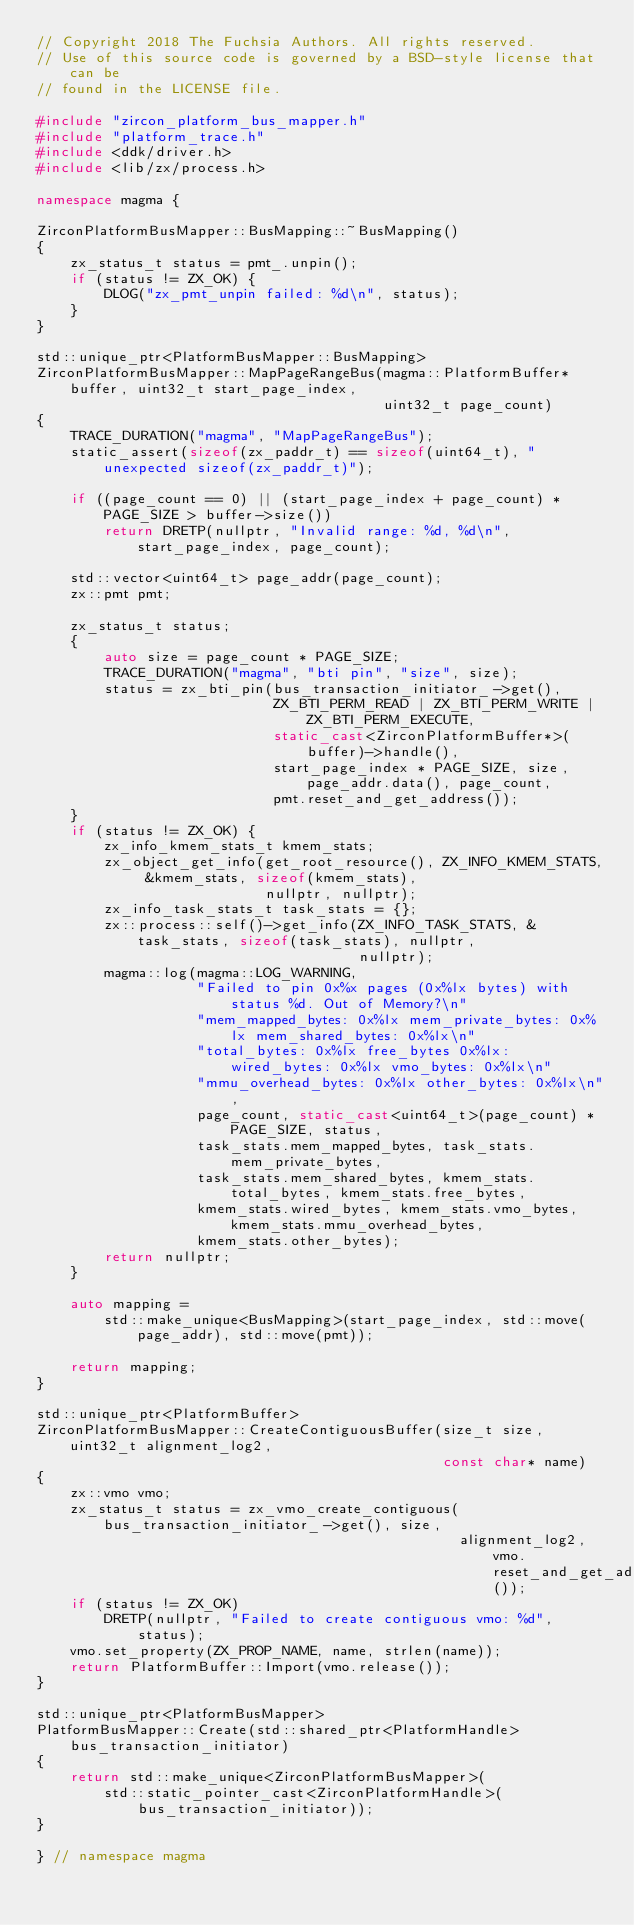Convert code to text. <code><loc_0><loc_0><loc_500><loc_500><_C++_>// Copyright 2018 The Fuchsia Authors. All rights reserved.
// Use of this source code is governed by a BSD-style license that can be
// found in the LICENSE file.

#include "zircon_platform_bus_mapper.h"
#include "platform_trace.h"
#include <ddk/driver.h>
#include <lib/zx/process.h>

namespace magma {

ZirconPlatformBusMapper::BusMapping::~BusMapping()
{
    zx_status_t status = pmt_.unpin();
    if (status != ZX_OK) {
        DLOG("zx_pmt_unpin failed: %d\n", status);
    }
}

std::unique_ptr<PlatformBusMapper::BusMapping>
ZirconPlatformBusMapper::MapPageRangeBus(magma::PlatformBuffer* buffer, uint32_t start_page_index,
                                         uint32_t page_count)
{
    TRACE_DURATION("magma", "MapPageRangeBus");
    static_assert(sizeof(zx_paddr_t) == sizeof(uint64_t), "unexpected sizeof(zx_paddr_t)");

    if ((page_count == 0) || (start_page_index + page_count) * PAGE_SIZE > buffer->size())
        return DRETP(nullptr, "Invalid range: %d, %d\n", start_page_index, page_count);

    std::vector<uint64_t> page_addr(page_count);
    zx::pmt pmt;

    zx_status_t status;
    {
        auto size = page_count * PAGE_SIZE;
        TRACE_DURATION("magma", "bti pin", "size", size);
        status = zx_bti_pin(bus_transaction_initiator_->get(),
                            ZX_BTI_PERM_READ | ZX_BTI_PERM_WRITE | ZX_BTI_PERM_EXECUTE,
                            static_cast<ZirconPlatformBuffer*>(buffer)->handle(),
                            start_page_index * PAGE_SIZE, size, page_addr.data(), page_count,
                            pmt.reset_and_get_address());
    }
    if (status != ZX_OK) {
        zx_info_kmem_stats_t kmem_stats;
        zx_object_get_info(get_root_resource(), ZX_INFO_KMEM_STATS, &kmem_stats, sizeof(kmem_stats),
                           nullptr, nullptr);
        zx_info_task_stats_t task_stats = {};
        zx::process::self()->get_info(ZX_INFO_TASK_STATS, &task_stats, sizeof(task_stats), nullptr,
                                      nullptr);
        magma::log(magma::LOG_WARNING,
                   "Failed to pin 0x%x pages (0x%lx bytes) with status %d. Out of Memory?\n"
                   "mem_mapped_bytes: 0x%lx mem_private_bytes: 0x%lx mem_shared_bytes: 0x%lx\n"
                   "total_bytes: 0x%lx free_bytes 0x%lx: wired_bytes: 0x%lx vmo_bytes: 0x%lx\n"
                   "mmu_overhead_bytes: 0x%lx other_bytes: 0x%lx\n",
                   page_count, static_cast<uint64_t>(page_count) * PAGE_SIZE, status,
                   task_stats.mem_mapped_bytes, task_stats.mem_private_bytes,
                   task_stats.mem_shared_bytes, kmem_stats.total_bytes, kmem_stats.free_bytes,
                   kmem_stats.wired_bytes, kmem_stats.vmo_bytes, kmem_stats.mmu_overhead_bytes,
                   kmem_stats.other_bytes);
        return nullptr;
    }

    auto mapping =
        std::make_unique<BusMapping>(start_page_index, std::move(page_addr), std::move(pmt));

    return mapping;
}

std::unique_ptr<PlatformBuffer>
ZirconPlatformBusMapper::CreateContiguousBuffer(size_t size, uint32_t alignment_log2,
                                                const char* name)
{
    zx::vmo vmo;
    zx_status_t status = zx_vmo_create_contiguous(bus_transaction_initiator_->get(), size,
                                                  alignment_log2, vmo.reset_and_get_address());
    if (status != ZX_OK)
        DRETP(nullptr, "Failed to create contiguous vmo: %d", status);
    vmo.set_property(ZX_PROP_NAME, name, strlen(name));
    return PlatformBuffer::Import(vmo.release());
}

std::unique_ptr<PlatformBusMapper>
PlatformBusMapper::Create(std::shared_ptr<PlatformHandle> bus_transaction_initiator)
{
    return std::make_unique<ZirconPlatformBusMapper>(
        std::static_pointer_cast<ZirconPlatformHandle>(bus_transaction_initiator));
}

} // namespace magma
</code> 